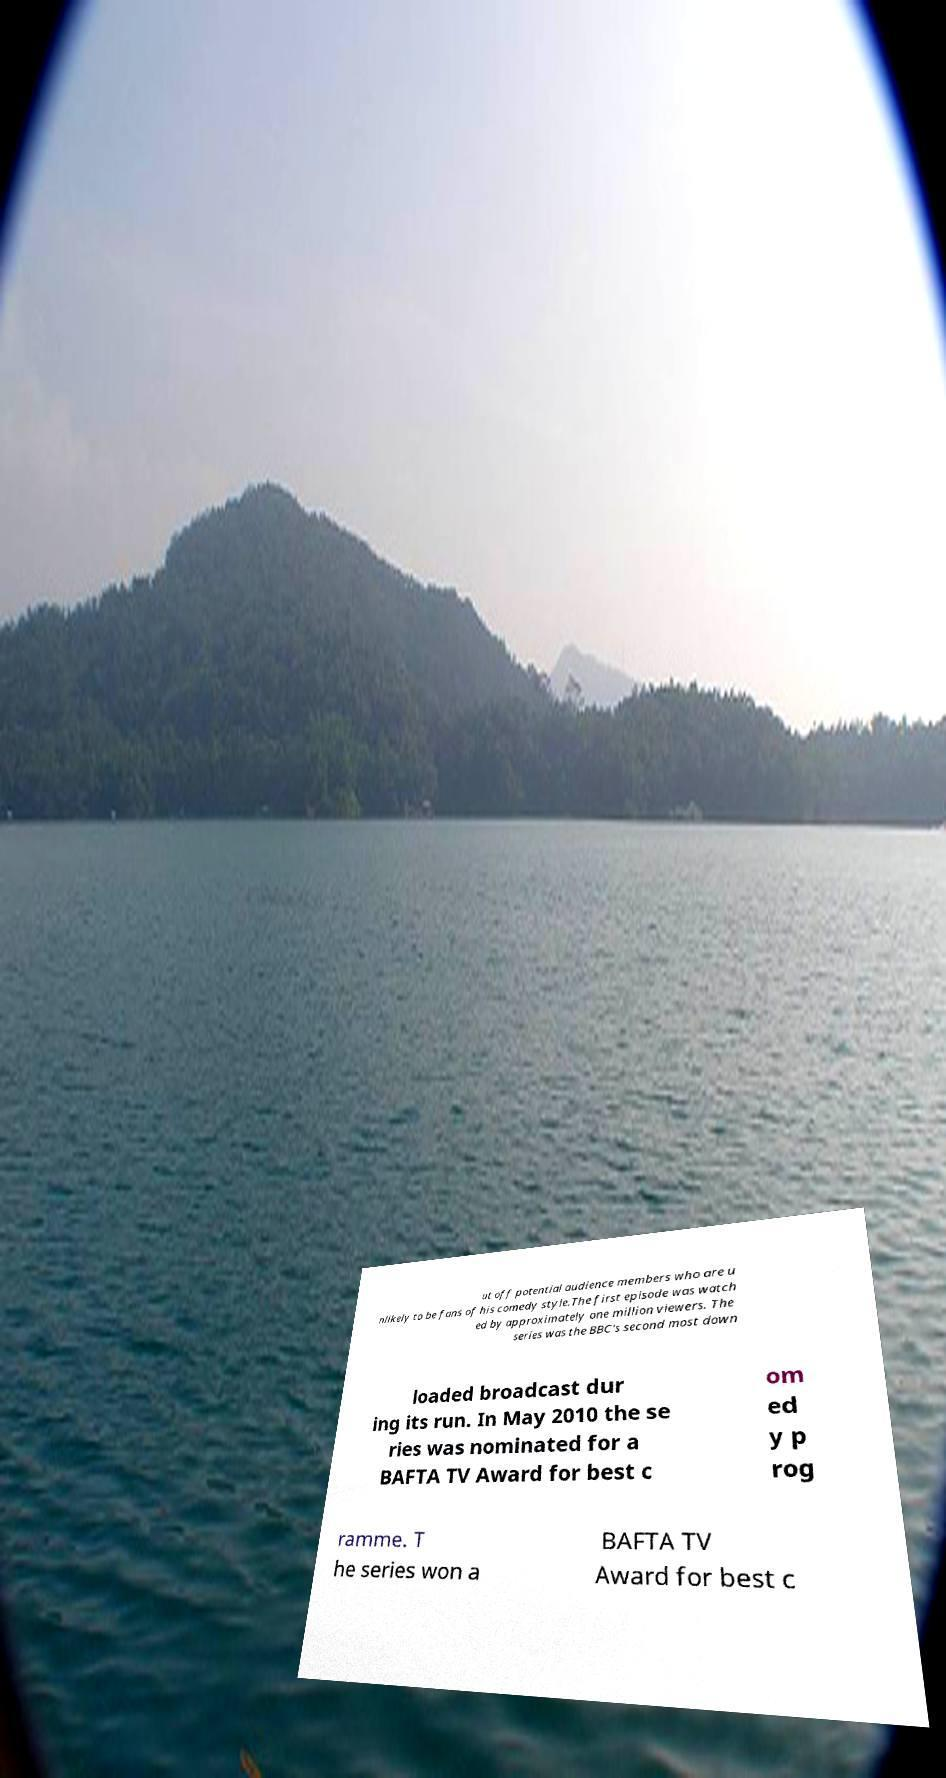Please identify and transcribe the text found in this image. ut off potential audience members who are u nlikely to be fans of his comedy style.The first episode was watch ed by approximately one million viewers. The series was the BBC's second most down loaded broadcast dur ing its run. In May 2010 the se ries was nominated for a BAFTA TV Award for best c om ed y p rog ramme. T he series won a BAFTA TV Award for best c 